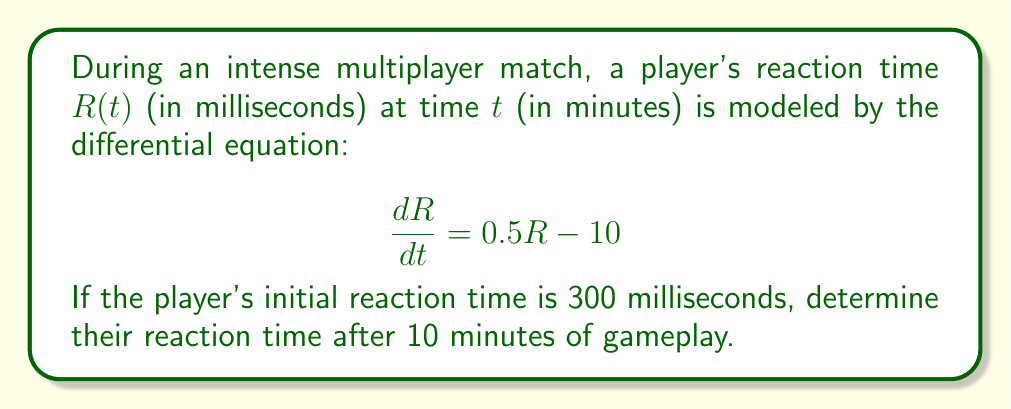Solve this math problem. To solve this problem, we need to follow these steps:

1) We have a first-order linear differential equation:
   $$\frac{dR}{dt} = 0.5R - 10$$

2) This is in the standard form $\frac{dy}{dx} + P(x)y = Q(x)$, where:
   $\frac{dR}{dt} - 0.5R = -10$

3) The integrating factor is $e^{\int P(x)dx} = e^{-0.5t}$

4) Multiplying both sides by the integrating factor:
   $$e^{-0.5t}\frac{dR}{dt} - 0.5e^{-0.5t}R = -10e^{-0.5t}$$

5) The left side is now the derivative of $Re^{-0.5t}$:
   $$\frac{d}{dt}(Re^{-0.5t}) = -10e^{-0.5t}$$

6) Integrating both sides:
   $$Re^{-0.5t} = 20e^{-0.5t} + C$$

7) Solving for R:
   $$R = 20 + Ce^{0.5t}$$

8) Using the initial condition R(0) = 300:
   $$300 = 20 + C$$
   $$C = 280$$

9) Therefore, the general solution is:
   $$R(t) = 20 + 280e^{0.5t}$$

10) To find R(10), we substitute t = 10:
    $$R(10) = 20 + 280e^{0.5(10)} = 20 + 280e^5$$

11) Calculate the final value:
    $$R(10) = 20 + 280 * 148.4131591 = 41,575.68 \text{ milliseconds}$$
Answer: The player's reaction time after 10 minutes of gameplay is approximately 41,576 milliseconds. 